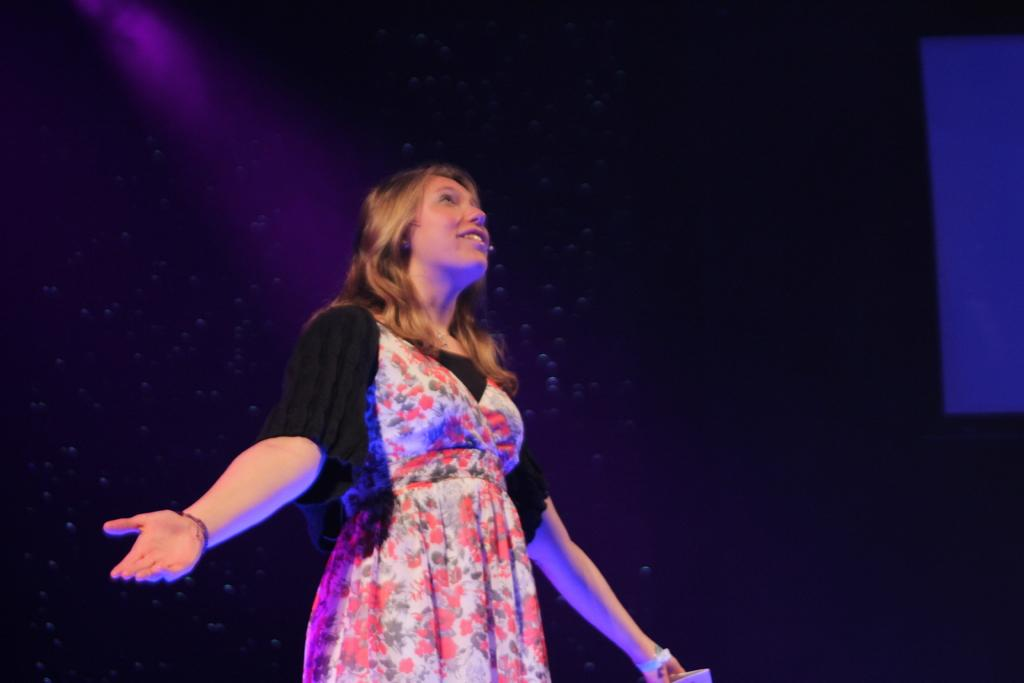Who is the main subject in the image? There is a woman in the center of the image. What is the woman wearing? The woman is wearing a floral frock. What is the woman doing in the image? The woman is standing. What is the color of the background in the image? The background of the image is black in color. Can you see any ducks swimming in the water in the image? There is no water or ducks present in the image. What type of plant is growing near the woman in the image? There is no plant visible near the woman in the image. 